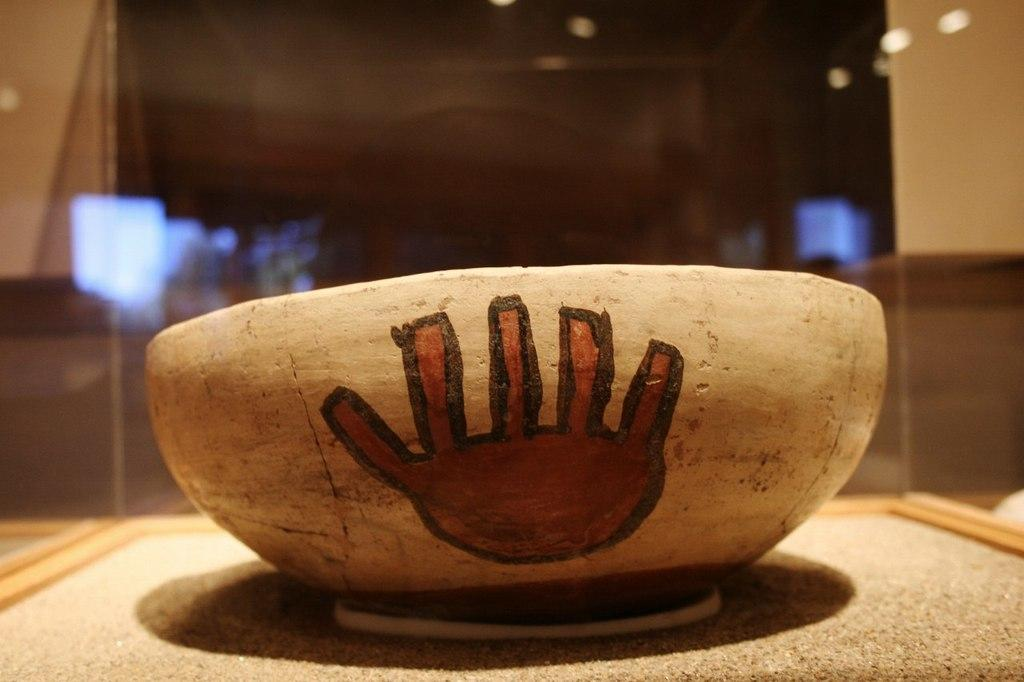What is the color of the object in the image? The object in the image has a brown color. What can be seen in the background of the image? The background of the image includes glass. What type of legal advice is the farmer seeking in the image? There is no lawyer, farmer, or any indication of legal advice in the image; it only features a brown object and a background with glass. 